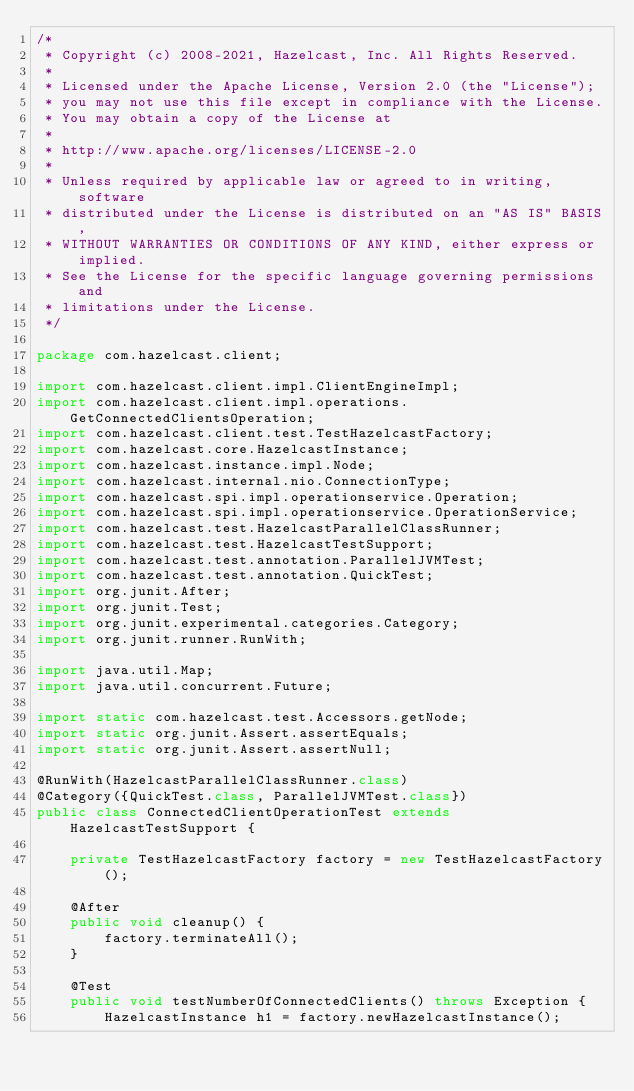<code> <loc_0><loc_0><loc_500><loc_500><_Java_>/*
 * Copyright (c) 2008-2021, Hazelcast, Inc. All Rights Reserved.
 *
 * Licensed under the Apache License, Version 2.0 (the "License");
 * you may not use this file except in compliance with the License.
 * You may obtain a copy of the License at
 *
 * http://www.apache.org/licenses/LICENSE-2.0
 *
 * Unless required by applicable law or agreed to in writing, software
 * distributed under the License is distributed on an "AS IS" BASIS,
 * WITHOUT WARRANTIES OR CONDITIONS OF ANY KIND, either express or implied.
 * See the License for the specific language governing permissions and
 * limitations under the License.
 */

package com.hazelcast.client;

import com.hazelcast.client.impl.ClientEngineImpl;
import com.hazelcast.client.impl.operations.GetConnectedClientsOperation;
import com.hazelcast.client.test.TestHazelcastFactory;
import com.hazelcast.core.HazelcastInstance;
import com.hazelcast.instance.impl.Node;
import com.hazelcast.internal.nio.ConnectionType;
import com.hazelcast.spi.impl.operationservice.Operation;
import com.hazelcast.spi.impl.operationservice.OperationService;
import com.hazelcast.test.HazelcastParallelClassRunner;
import com.hazelcast.test.HazelcastTestSupport;
import com.hazelcast.test.annotation.ParallelJVMTest;
import com.hazelcast.test.annotation.QuickTest;
import org.junit.After;
import org.junit.Test;
import org.junit.experimental.categories.Category;
import org.junit.runner.RunWith;

import java.util.Map;
import java.util.concurrent.Future;

import static com.hazelcast.test.Accessors.getNode;
import static org.junit.Assert.assertEquals;
import static org.junit.Assert.assertNull;

@RunWith(HazelcastParallelClassRunner.class)
@Category({QuickTest.class, ParallelJVMTest.class})
public class ConnectedClientOperationTest extends HazelcastTestSupport {

    private TestHazelcastFactory factory = new TestHazelcastFactory();

    @After
    public void cleanup() {
        factory.terminateAll();
    }

    @Test
    public void testNumberOfConnectedClients() throws Exception {
        HazelcastInstance h1 = factory.newHazelcastInstance();</code> 